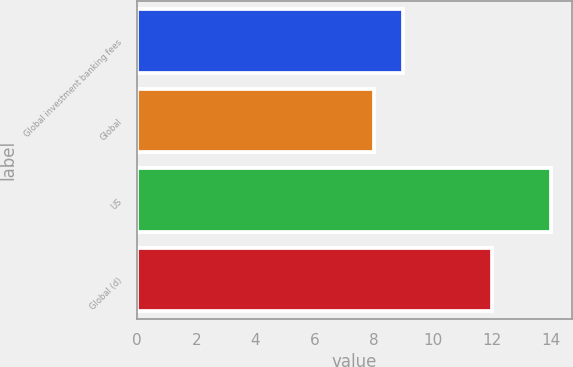<chart> <loc_0><loc_0><loc_500><loc_500><bar_chart><fcel>Global investment banking fees<fcel>Global<fcel>US<fcel>Global (d)<nl><fcel>9<fcel>8<fcel>14<fcel>12<nl></chart> 